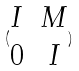<formula> <loc_0><loc_0><loc_500><loc_500>( \begin{matrix} I & M \\ 0 & I \end{matrix} )</formula> 